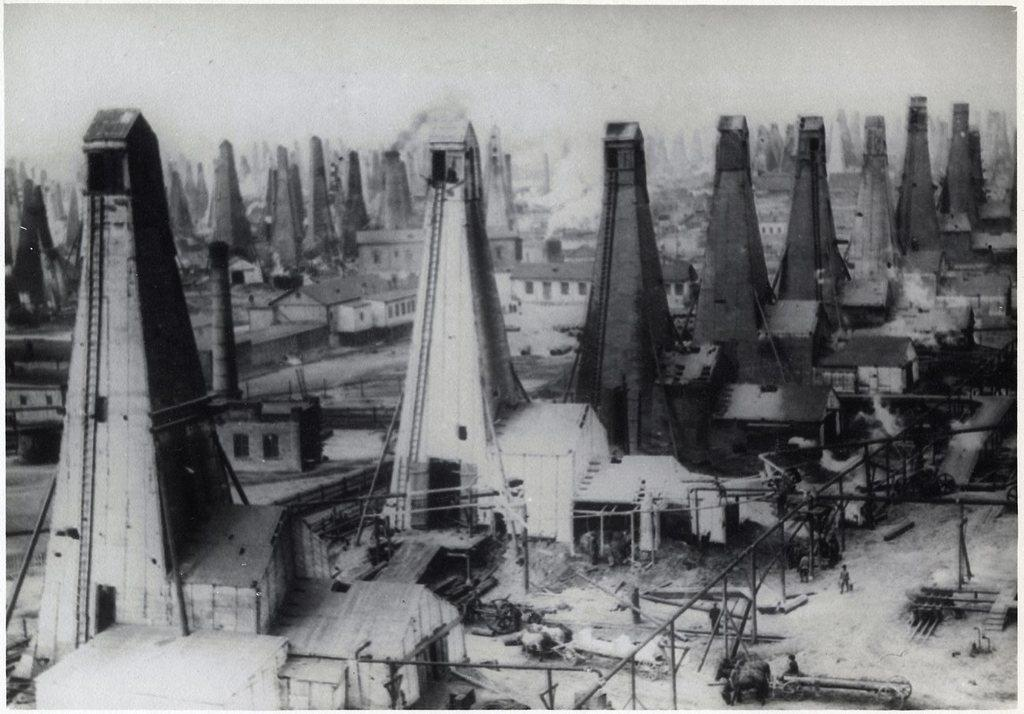What is the color scheme of the image? The image is in black and white. What type of structures can be seen in the image? There are factories in the image. What objects are present in the image besides the factories? There are poles in the image. Are there any living beings visible in the image? Yes, there are people in the image. Can you hear the whistle of the duck in the image? There is no duck or whistle present in the image; it only features factories, poles, and people. 